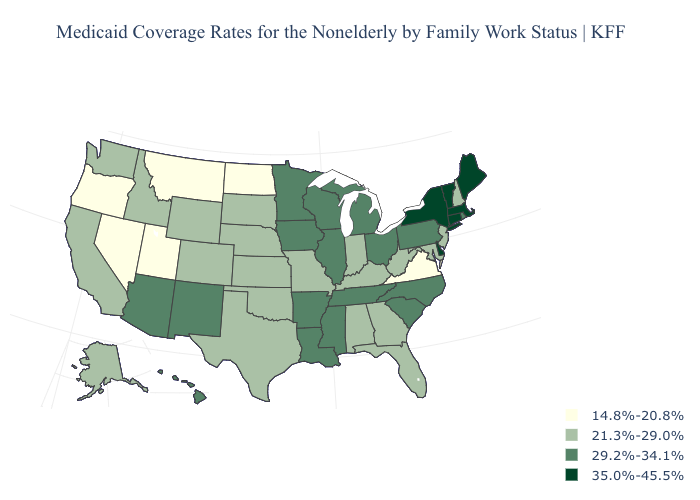Name the states that have a value in the range 14.8%-20.8%?
Give a very brief answer. Montana, Nevada, North Dakota, Oregon, Utah, Virginia. Name the states that have a value in the range 29.2%-34.1%?
Short answer required. Arizona, Arkansas, Hawaii, Illinois, Iowa, Louisiana, Michigan, Minnesota, Mississippi, New Mexico, North Carolina, Ohio, Pennsylvania, Rhode Island, South Carolina, Tennessee, Wisconsin. Does Florida have the lowest value in the South?
Answer briefly. No. What is the value of South Carolina?
Answer briefly. 29.2%-34.1%. What is the highest value in the Northeast ?
Quick response, please. 35.0%-45.5%. Which states have the lowest value in the South?
Concise answer only. Virginia. Among the states that border Texas , which have the highest value?
Concise answer only. Arkansas, Louisiana, New Mexico. Among the states that border Michigan , does Wisconsin have the lowest value?
Keep it brief. No. Name the states that have a value in the range 21.3%-29.0%?
Answer briefly. Alabama, Alaska, California, Colorado, Florida, Georgia, Idaho, Indiana, Kansas, Kentucky, Maryland, Missouri, Nebraska, New Hampshire, New Jersey, Oklahoma, South Dakota, Texas, Washington, West Virginia, Wyoming. Name the states that have a value in the range 21.3%-29.0%?
Write a very short answer. Alabama, Alaska, California, Colorado, Florida, Georgia, Idaho, Indiana, Kansas, Kentucky, Maryland, Missouri, Nebraska, New Hampshire, New Jersey, Oklahoma, South Dakota, Texas, Washington, West Virginia, Wyoming. Name the states that have a value in the range 21.3%-29.0%?
Be succinct. Alabama, Alaska, California, Colorado, Florida, Georgia, Idaho, Indiana, Kansas, Kentucky, Maryland, Missouri, Nebraska, New Hampshire, New Jersey, Oklahoma, South Dakota, Texas, Washington, West Virginia, Wyoming. What is the value of Florida?
Give a very brief answer. 21.3%-29.0%. What is the lowest value in the USA?
Concise answer only. 14.8%-20.8%. How many symbols are there in the legend?
Keep it brief. 4. 